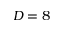Convert formula to latex. <formula><loc_0><loc_0><loc_500><loc_500>D = 8</formula> 